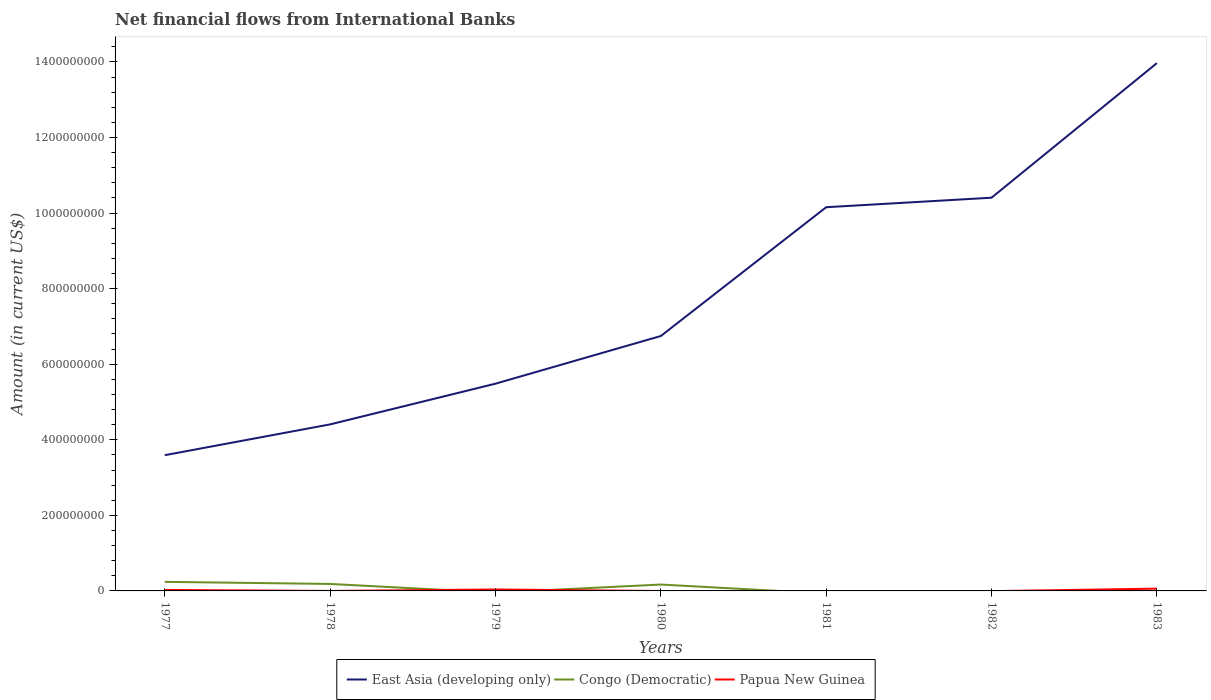How many different coloured lines are there?
Provide a short and direct response. 3. Does the line corresponding to Papua New Guinea intersect with the line corresponding to East Asia (developing only)?
Make the answer very short. No. What is the total net financial aid flows in Congo (Democratic) in the graph?
Offer a very short reply. 7.11e+06. What is the difference between the highest and the second highest net financial aid flows in Papua New Guinea?
Give a very brief answer. 6.05e+06. How many years are there in the graph?
Make the answer very short. 7. What is the title of the graph?
Ensure brevity in your answer.  Net financial flows from International Banks. What is the label or title of the X-axis?
Provide a succinct answer. Years. What is the label or title of the Y-axis?
Make the answer very short. Amount (in current US$). What is the Amount (in current US$) of East Asia (developing only) in 1977?
Keep it short and to the point. 3.59e+08. What is the Amount (in current US$) in Congo (Democratic) in 1977?
Provide a succinct answer. 2.40e+07. What is the Amount (in current US$) in Papua New Guinea in 1977?
Provide a succinct answer. 2.61e+06. What is the Amount (in current US$) of East Asia (developing only) in 1978?
Provide a short and direct response. 4.41e+08. What is the Amount (in current US$) of Congo (Democratic) in 1978?
Your answer should be compact. 1.85e+07. What is the Amount (in current US$) of Papua New Guinea in 1978?
Keep it short and to the point. 0. What is the Amount (in current US$) of East Asia (developing only) in 1979?
Make the answer very short. 5.48e+08. What is the Amount (in current US$) of Congo (Democratic) in 1979?
Provide a succinct answer. 0. What is the Amount (in current US$) of Papua New Guinea in 1979?
Offer a terse response. 3.85e+06. What is the Amount (in current US$) in East Asia (developing only) in 1980?
Your response must be concise. 6.75e+08. What is the Amount (in current US$) in Congo (Democratic) in 1980?
Give a very brief answer. 1.69e+07. What is the Amount (in current US$) of Papua New Guinea in 1980?
Ensure brevity in your answer.  0. What is the Amount (in current US$) of East Asia (developing only) in 1981?
Offer a terse response. 1.02e+09. What is the Amount (in current US$) in East Asia (developing only) in 1982?
Offer a terse response. 1.04e+09. What is the Amount (in current US$) of East Asia (developing only) in 1983?
Your answer should be compact. 1.40e+09. What is the Amount (in current US$) of Papua New Guinea in 1983?
Provide a succinct answer. 6.05e+06. Across all years, what is the maximum Amount (in current US$) in East Asia (developing only)?
Ensure brevity in your answer.  1.40e+09. Across all years, what is the maximum Amount (in current US$) of Congo (Democratic)?
Make the answer very short. 2.40e+07. Across all years, what is the maximum Amount (in current US$) in Papua New Guinea?
Your response must be concise. 6.05e+06. Across all years, what is the minimum Amount (in current US$) in East Asia (developing only)?
Ensure brevity in your answer.  3.59e+08. Across all years, what is the minimum Amount (in current US$) of Congo (Democratic)?
Your answer should be compact. 0. What is the total Amount (in current US$) of East Asia (developing only) in the graph?
Make the answer very short. 5.48e+09. What is the total Amount (in current US$) of Congo (Democratic) in the graph?
Your answer should be very brief. 5.94e+07. What is the total Amount (in current US$) in Papua New Guinea in the graph?
Your response must be concise. 1.25e+07. What is the difference between the Amount (in current US$) of East Asia (developing only) in 1977 and that in 1978?
Offer a very short reply. -8.15e+07. What is the difference between the Amount (in current US$) of Congo (Democratic) in 1977 and that in 1978?
Offer a very short reply. 5.53e+06. What is the difference between the Amount (in current US$) in East Asia (developing only) in 1977 and that in 1979?
Provide a succinct answer. -1.89e+08. What is the difference between the Amount (in current US$) in Papua New Guinea in 1977 and that in 1979?
Your answer should be compact. -1.24e+06. What is the difference between the Amount (in current US$) of East Asia (developing only) in 1977 and that in 1980?
Your answer should be compact. -3.15e+08. What is the difference between the Amount (in current US$) in Congo (Democratic) in 1977 and that in 1980?
Ensure brevity in your answer.  7.11e+06. What is the difference between the Amount (in current US$) of East Asia (developing only) in 1977 and that in 1981?
Ensure brevity in your answer.  -6.56e+08. What is the difference between the Amount (in current US$) in East Asia (developing only) in 1977 and that in 1982?
Your response must be concise. -6.81e+08. What is the difference between the Amount (in current US$) of East Asia (developing only) in 1977 and that in 1983?
Offer a terse response. -1.04e+09. What is the difference between the Amount (in current US$) of Papua New Guinea in 1977 and that in 1983?
Offer a very short reply. -3.44e+06. What is the difference between the Amount (in current US$) in East Asia (developing only) in 1978 and that in 1979?
Your response must be concise. -1.08e+08. What is the difference between the Amount (in current US$) of East Asia (developing only) in 1978 and that in 1980?
Ensure brevity in your answer.  -2.34e+08. What is the difference between the Amount (in current US$) in Congo (Democratic) in 1978 and that in 1980?
Your response must be concise. 1.58e+06. What is the difference between the Amount (in current US$) of East Asia (developing only) in 1978 and that in 1981?
Make the answer very short. -5.75e+08. What is the difference between the Amount (in current US$) in East Asia (developing only) in 1978 and that in 1982?
Offer a terse response. -6.00e+08. What is the difference between the Amount (in current US$) of East Asia (developing only) in 1978 and that in 1983?
Give a very brief answer. -9.56e+08. What is the difference between the Amount (in current US$) of East Asia (developing only) in 1979 and that in 1980?
Provide a short and direct response. -1.26e+08. What is the difference between the Amount (in current US$) in East Asia (developing only) in 1979 and that in 1981?
Make the answer very short. -4.67e+08. What is the difference between the Amount (in current US$) in East Asia (developing only) in 1979 and that in 1982?
Provide a succinct answer. -4.92e+08. What is the difference between the Amount (in current US$) in East Asia (developing only) in 1979 and that in 1983?
Offer a very short reply. -8.48e+08. What is the difference between the Amount (in current US$) in Papua New Guinea in 1979 and that in 1983?
Give a very brief answer. -2.20e+06. What is the difference between the Amount (in current US$) of East Asia (developing only) in 1980 and that in 1981?
Your response must be concise. -3.41e+08. What is the difference between the Amount (in current US$) in East Asia (developing only) in 1980 and that in 1982?
Your answer should be compact. -3.66e+08. What is the difference between the Amount (in current US$) of East Asia (developing only) in 1980 and that in 1983?
Make the answer very short. -7.22e+08. What is the difference between the Amount (in current US$) of East Asia (developing only) in 1981 and that in 1982?
Your answer should be very brief. -2.52e+07. What is the difference between the Amount (in current US$) of East Asia (developing only) in 1981 and that in 1983?
Your answer should be very brief. -3.81e+08. What is the difference between the Amount (in current US$) in East Asia (developing only) in 1982 and that in 1983?
Your response must be concise. -3.56e+08. What is the difference between the Amount (in current US$) of East Asia (developing only) in 1977 and the Amount (in current US$) of Congo (Democratic) in 1978?
Ensure brevity in your answer.  3.41e+08. What is the difference between the Amount (in current US$) in East Asia (developing only) in 1977 and the Amount (in current US$) in Papua New Guinea in 1979?
Provide a succinct answer. 3.55e+08. What is the difference between the Amount (in current US$) in Congo (Democratic) in 1977 and the Amount (in current US$) in Papua New Guinea in 1979?
Provide a succinct answer. 2.02e+07. What is the difference between the Amount (in current US$) of East Asia (developing only) in 1977 and the Amount (in current US$) of Congo (Democratic) in 1980?
Your response must be concise. 3.42e+08. What is the difference between the Amount (in current US$) of East Asia (developing only) in 1977 and the Amount (in current US$) of Papua New Guinea in 1983?
Offer a terse response. 3.53e+08. What is the difference between the Amount (in current US$) of Congo (Democratic) in 1977 and the Amount (in current US$) of Papua New Guinea in 1983?
Keep it short and to the point. 1.79e+07. What is the difference between the Amount (in current US$) of East Asia (developing only) in 1978 and the Amount (in current US$) of Papua New Guinea in 1979?
Ensure brevity in your answer.  4.37e+08. What is the difference between the Amount (in current US$) in Congo (Democratic) in 1978 and the Amount (in current US$) in Papua New Guinea in 1979?
Make the answer very short. 1.46e+07. What is the difference between the Amount (in current US$) of East Asia (developing only) in 1978 and the Amount (in current US$) of Congo (Democratic) in 1980?
Ensure brevity in your answer.  4.24e+08. What is the difference between the Amount (in current US$) of East Asia (developing only) in 1978 and the Amount (in current US$) of Papua New Guinea in 1983?
Offer a very short reply. 4.35e+08. What is the difference between the Amount (in current US$) in Congo (Democratic) in 1978 and the Amount (in current US$) in Papua New Guinea in 1983?
Make the answer very short. 1.24e+07. What is the difference between the Amount (in current US$) in East Asia (developing only) in 1979 and the Amount (in current US$) in Congo (Democratic) in 1980?
Provide a short and direct response. 5.32e+08. What is the difference between the Amount (in current US$) in East Asia (developing only) in 1979 and the Amount (in current US$) in Papua New Guinea in 1983?
Ensure brevity in your answer.  5.42e+08. What is the difference between the Amount (in current US$) in East Asia (developing only) in 1980 and the Amount (in current US$) in Papua New Guinea in 1983?
Ensure brevity in your answer.  6.69e+08. What is the difference between the Amount (in current US$) in Congo (Democratic) in 1980 and the Amount (in current US$) in Papua New Guinea in 1983?
Offer a terse response. 1.08e+07. What is the difference between the Amount (in current US$) in East Asia (developing only) in 1981 and the Amount (in current US$) in Papua New Guinea in 1983?
Keep it short and to the point. 1.01e+09. What is the difference between the Amount (in current US$) of East Asia (developing only) in 1982 and the Amount (in current US$) of Papua New Guinea in 1983?
Provide a succinct answer. 1.03e+09. What is the average Amount (in current US$) of East Asia (developing only) per year?
Ensure brevity in your answer.  7.82e+08. What is the average Amount (in current US$) in Congo (Democratic) per year?
Keep it short and to the point. 8.48e+06. What is the average Amount (in current US$) in Papua New Guinea per year?
Your answer should be compact. 1.79e+06. In the year 1977, what is the difference between the Amount (in current US$) of East Asia (developing only) and Amount (in current US$) of Congo (Democratic)?
Give a very brief answer. 3.35e+08. In the year 1977, what is the difference between the Amount (in current US$) of East Asia (developing only) and Amount (in current US$) of Papua New Guinea?
Your answer should be compact. 3.57e+08. In the year 1977, what is the difference between the Amount (in current US$) in Congo (Democratic) and Amount (in current US$) in Papua New Guinea?
Your answer should be very brief. 2.14e+07. In the year 1978, what is the difference between the Amount (in current US$) in East Asia (developing only) and Amount (in current US$) in Congo (Democratic)?
Offer a very short reply. 4.22e+08. In the year 1979, what is the difference between the Amount (in current US$) of East Asia (developing only) and Amount (in current US$) of Papua New Guinea?
Your answer should be compact. 5.45e+08. In the year 1980, what is the difference between the Amount (in current US$) in East Asia (developing only) and Amount (in current US$) in Congo (Democratic)?
Make the answer very short. 6.58e+08. In the year 1983, what is the difference between the Amount (in current US$) in East Asia (developing only) and Amount (in current US$) in Papua New Guinea?
Your response must be concise. 1.39e+09. What is the ratio of the Amount (in current US$) in East Asia (developing only) in 1977 to that in 1978?
Your answer should be compact. 0.82. What is the ratio of the Amount (in current US$) in Congo (Democratic) in 1977 to that in 1978?
Keep it short and to the point. 1.3. What is the ratio of the Amount (in current US$) of East Asia (developing only) in 1977 to that in 1979?
Ensure brevity in your answer.  0.66. What is the ratio of the Amount (in current US$) of Papua New Guinea in 1977 to that in 1979?
Keep it short and to the point. 0.68. What is the ratio of the Amount (in current US$) of East Asia (developing only) in 1977 to that in 1980?
Offer a terse response. 0.53. What is the ratio of the Amount (in current US$) in Congo (Democratic) in 1977 to that in 1980?
Keep it short and to the point. 1.42. What is the ratio of the Amount (in current US$) in East Asia (developing only) in 1977 to that in 1981?
Your response must be concise. 0.35. What is the ratio of the Amount (in current US$) of East Asia (developing only) in 1977 to that in 1982?
Ensure brevity in your answer.  0.35. What is the ratio of the Amount (in current US$) of East Asia (developing only) in 1977 to that in 1983?
Make the answer very short. 0.26. What is the ratio of the Amount (in current US$) in Papua New Guinea in 1977 to that in 1983?
Your answer should be very brief. 0.43. What is the ratio of the Amount (in current US$) of East Asia (developing only) in 1978 to that in 1979?
Provide a succinct answer. 0.8. What is the ratio of the Amount (in current US$) of East Asia (developing only) in 1978 to that in 1980?
Make the answer very short. 0.65. What is the ratio of the Amount (in current US$) of Congo (Democratic) in 1978 to that in 1980?
Your response must be concise. 1.09. What is the ratio of the Amount (in current US$) in East Asia (developing only) in 1978 to that in 1981?
Keep it short and to the point. 0.43. What is the ratio of the Amount (in current US$) in East Asia (developing only) in 1978 to that in 1982?
Offer a very short reply. 0.42. What is the ratio of the Amount (in current US$) of East Asia (developing only) in 1978 to that in 1983?
Your answer should be very brief. 0.32. What is the ratio of the Amount (in current US$) of East Asia (developing only) in 1979 to that in 1980?
Ensure brevity in your answer.  0.81. What is the ratio of the Amount (in current US$) in East Asia (developing only) in 1979 to that in 1981?
Your response must be concise. 0.54. What is the ratio of the Amount (in current US$) of East Asia (developing only) in 1979 to that in 1982?
Provide a succinct answer. 0.53. What is the ratio of the Amount (in current US$) in East Asia (developing only) in 1979 to that in 1983?
Your answer should be compact. 0.39. What is the ratio of the Amount (in current US$) of Papua New Guinea in 1979 to that in 1983?
Make the answer very short. 0.64. What is the ratio of the Amount (in current US$) in East Asia (developing only) in 1980 to that in 1981?
Your response must be concise. 0.66. What is the ratio of the Amount (in current US$) of East Asia (developing only) in 1980 to that in 1982?
Offer a terse response. 0.65. What is the ratio of the Amount (in current US$) of East Asia (developing only) in 1980 to that in 1983?
Make the answer very short. 0.48. What is the ratio of the Amount (in current US$) of East Asia (developing only) in 1981 to that in 1982?
Make the answer very short. 0.98. What is the ratio of the Amount (in current US$) in East Asia (developing only) in 1981 to that in 1983?
Make the answer very short. 0.73. What is the ratio of the Amount (in current US$) of East Asia (developing only) in 1982 to that in 1983?
Offer a terse response. 0.74. What is the difference between the highest and the second highest Amount (in current US$) in East Asia (developing only)?
Give a very brief answer. 3.56e+08. What is the difference between the highest and the second highest Amount (in current US$) in Congo (Democratic)?
Your response must be concise. 5.53e+06. What is the difference between the highest and the second highest Amount (in current US$) of Papua New Guinea?
Provide a short and direct response. 2.20e+06. What is the difference between the highest and the lowest Amount (in current US$) in East Asia (developing only)?
Provide a succinct answer. 1.04e+09. What is the difference between the highest and the lowest Amount (in current US$) in Congo (Democratic)?
Offer a very short reply. 2.40e+07. What is the difference between the highest and the lowest Amount (in current US$) of Papua New Guinea?
Offer a very short reply. 6.05e+06. 